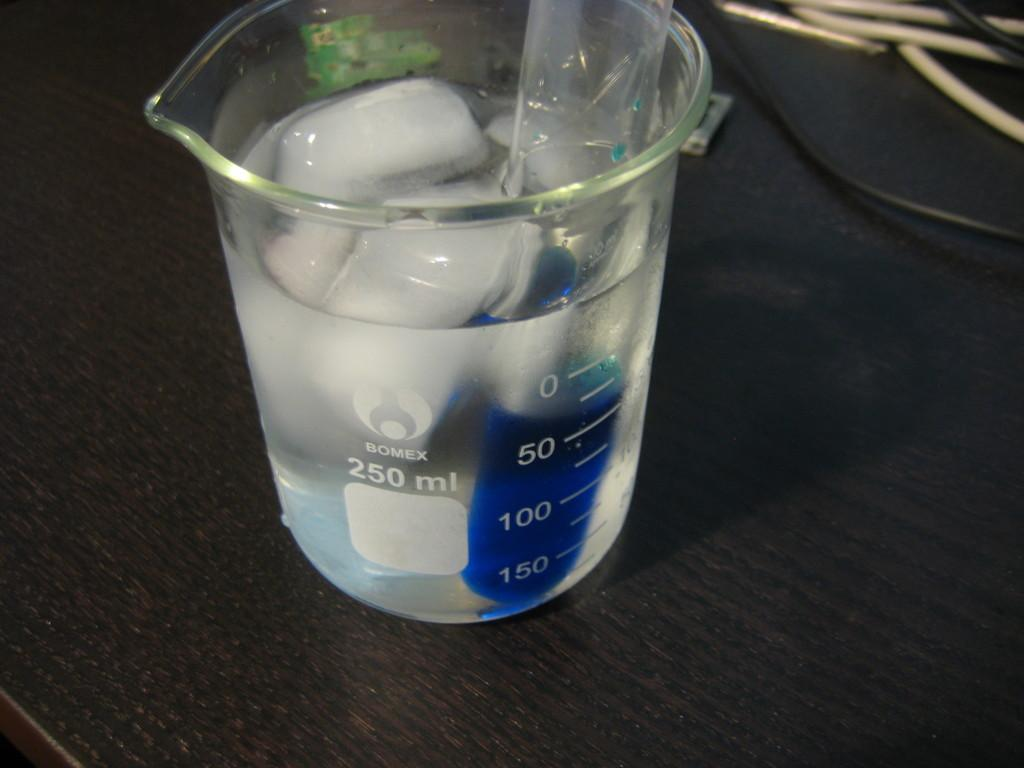<image>
Render a clear and concise summary of the photo. A Bomex 250 ml measuring cup is filled with ice water. 